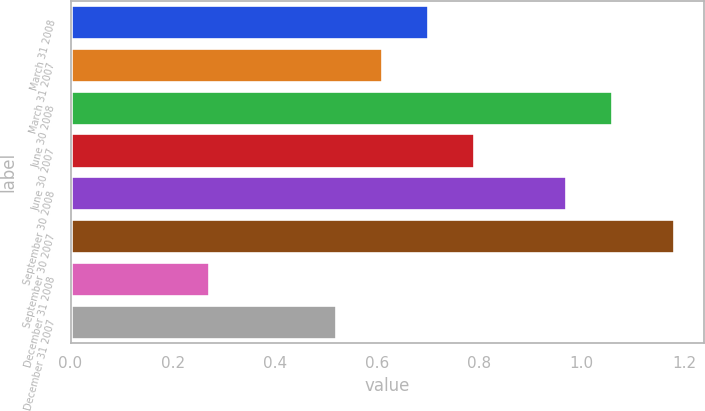Convert chart. <chart><loc_0><loc_0><loc_500><loc_500><bar_chart><fcel>March 31 2008<fcel>March 31 2007<fcel>June 30 2008<fcel>June 30 2007<fcel>September 30 2008<fcel>September 30 2007<fcel>December 31 2008<fcel>December 31 2007<nl><fcel>0.7<fcel>0.61<fcel>1.06<fcel>0.79<fcel>0.97<fcel>1.18<fcel>0.27<fcel>0.52<nl></chart> 